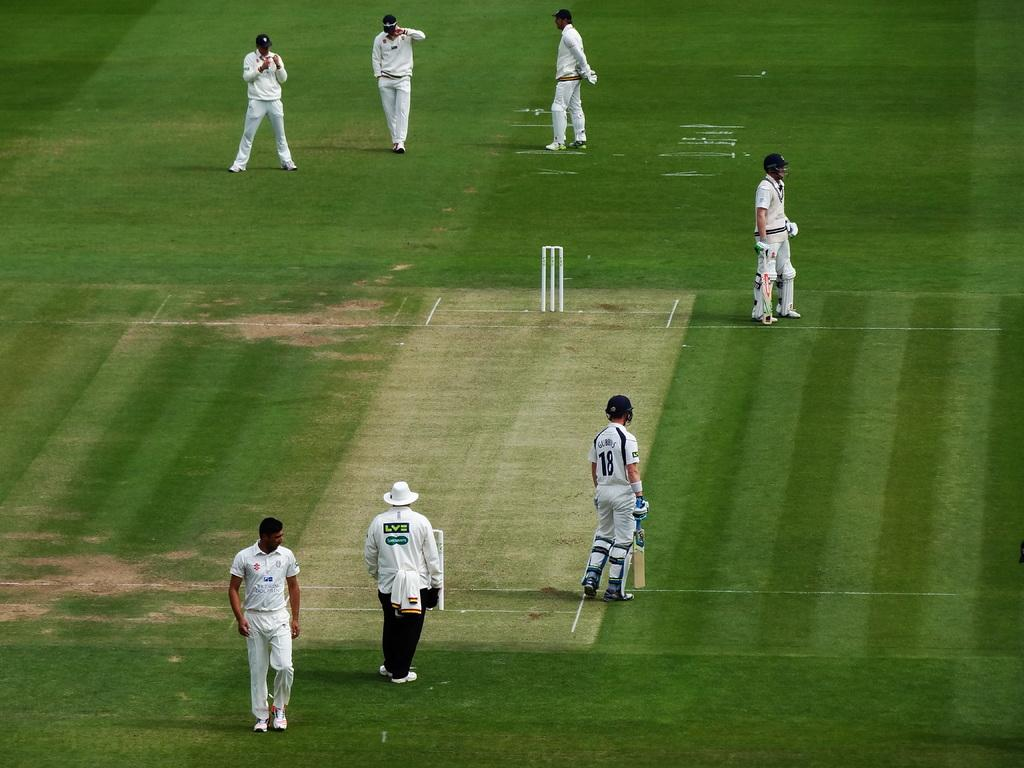<image>
Write a terse but informative summary of the picture. Man wearing a hat and a shirt that says "LVE" on the back walking on the grass with the players. 